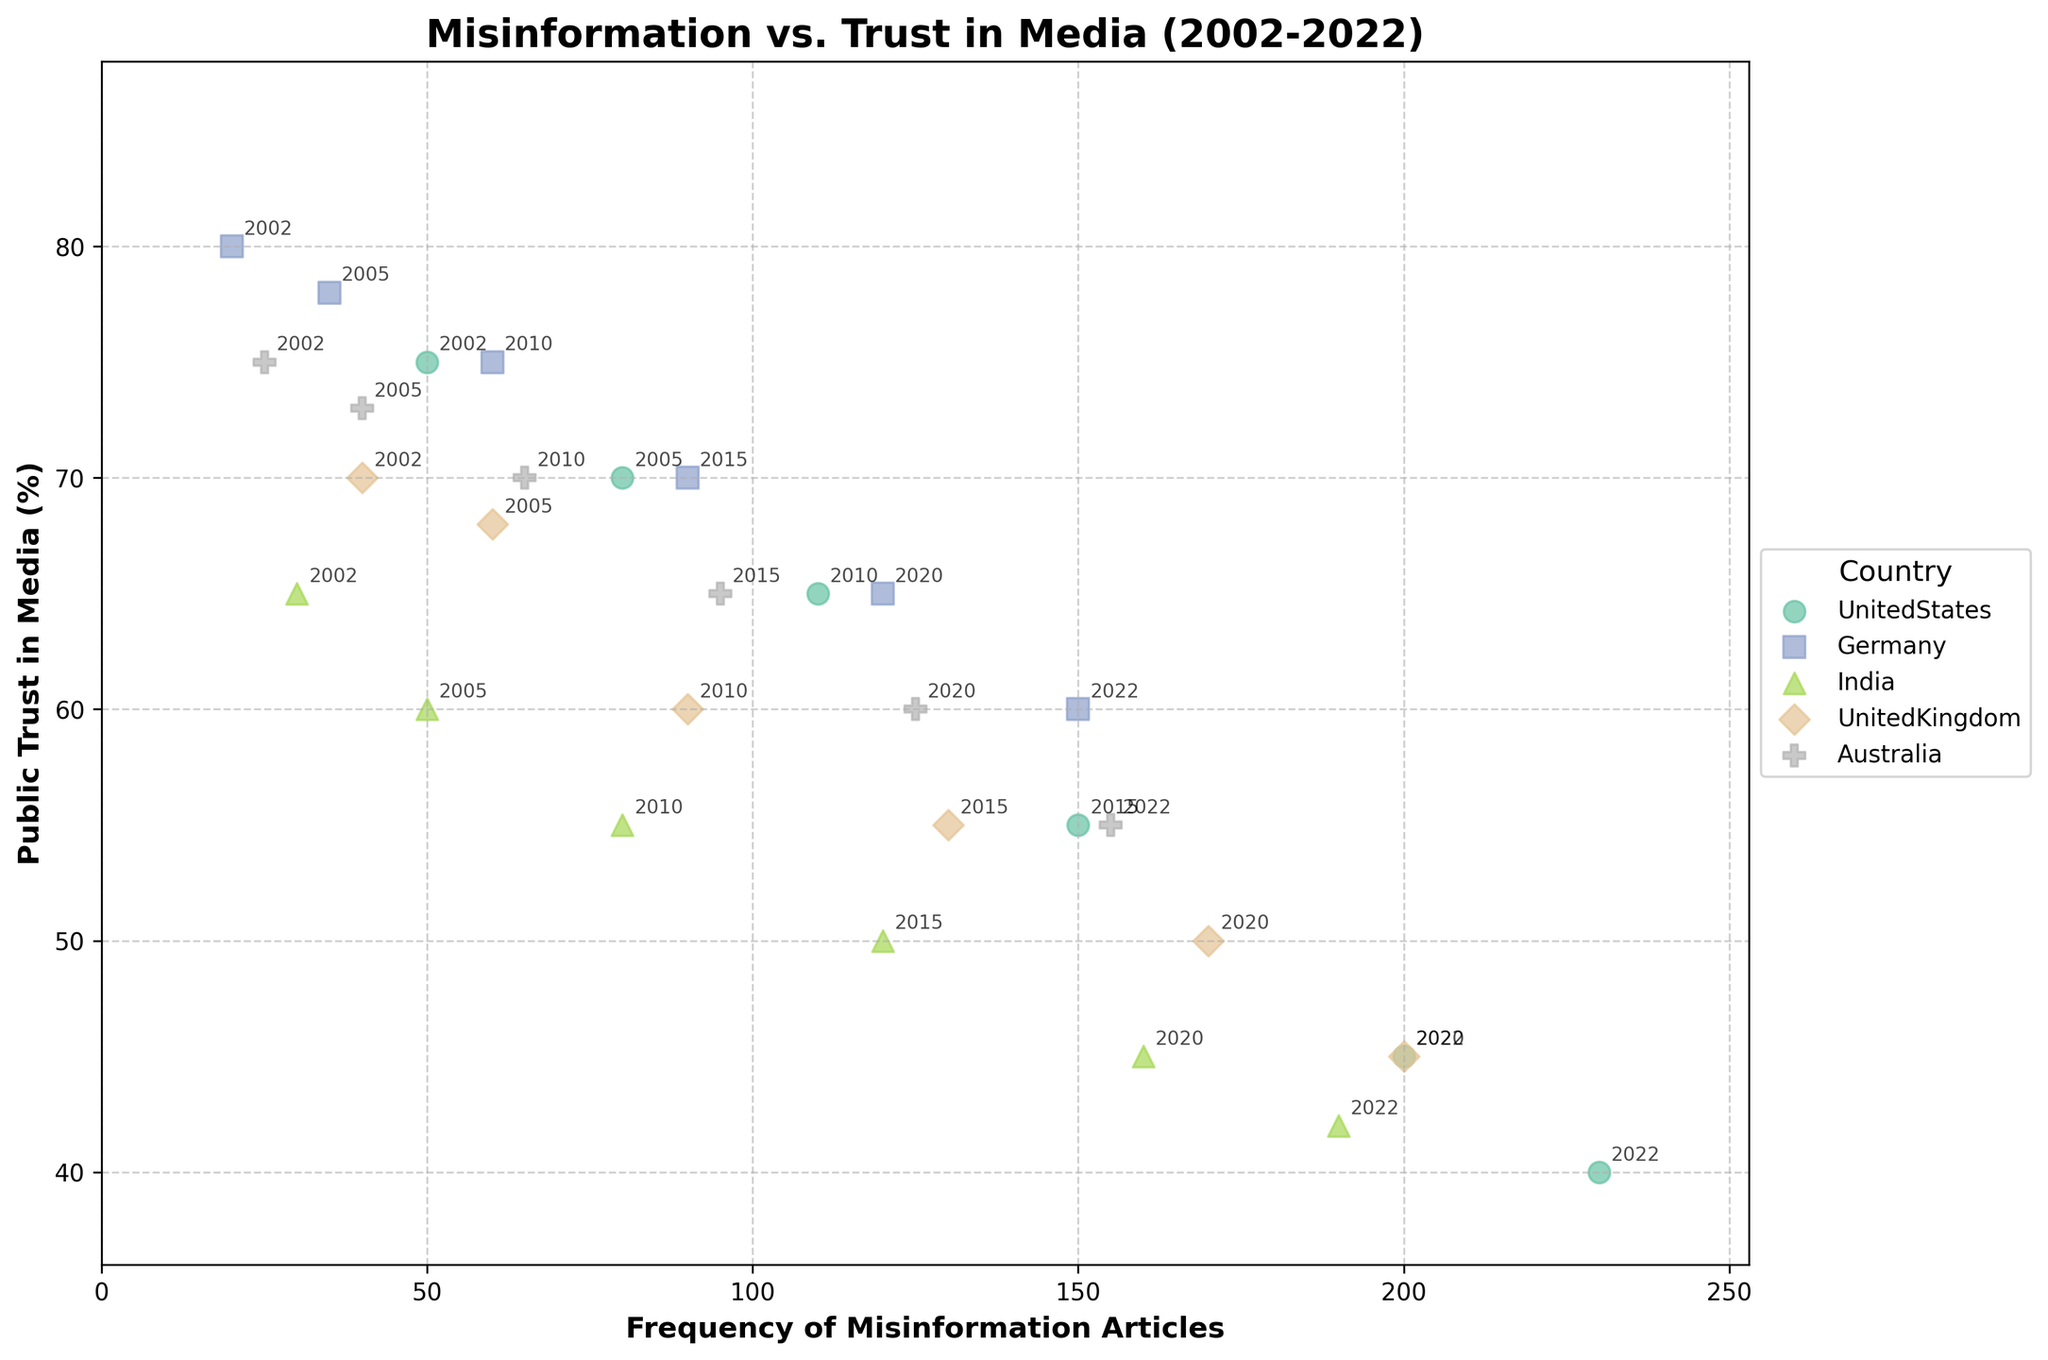How many countries are represented in the plot? The plot shows points in different colors and labels for various countries. If we count the unique colors and labels, we can determine the number of countries represented.
Answer: 5 Which country has the highest frequency of misinformation articles in 2022? By looking at the 2022 data points, we find the one with the highest value on the x-axis. The United States is positioned at 230 articles, which is the highest.
Answer: United States How did public trust in media change in Germany from 2002 to 2022? By comparing Germany's public trust in media in 2002 (80%) and 2022 (60%), we see a decrease of 20%.
Answer: Decreased by 20% Which country experienced the steepest decline in public trust in media over the two decades? Looking at the slope of the trend for each country from the starting to the ending point, India shows the steepest decline from 65% to 42%. Calculation: 65% - 42% = 23%.
Answer: India What is the overall trend between misinformation articles and public trust in media? The plot shows a general downward trend in public trust in media as the number of misinformation articles increases across different countries.
Answer: Negative correlation Which country had the lowest number of misinformation articles in 2002 and what was the corresponding trust in media? The country with the lowest value on the x-axis for the year 2002 is Germany with 20 articles and public trust of 80%.
Answer: Germany with 80% Which country has the most consistent trend in public trust compared to misinformation articles? By observing the scatter points and annotations for each country, Australia shows a slower decline in trust and a gradual increase in misinformation, indicating a more consistent trend.
Answer: Australia Between the United Kingdom and the United States, which had a greater decrease in public trust in media from 2002 to 2022? United Kingdom: 70% to 45% (25% decrease); United States: 75% to 40% (35% decrease). Thus, the United States had a greater decrease.
Answer: United States Among the represented countries, which one had the smallest increase in misinformation articles from 2002 to 2022? By comparing the differences in the number of misinformation articles from 2002 to 2022, Australia had the smallest increase, from 25 to 155 (130 articles).
Answer: Australia In which year did the United States see a sharp increase in misinformation articles, and how did public trust in media change that year? A sharp increase in misinformation articles for the United States is seen in 2015. The number of articles went from 110 to 150, and public trust dropped from 65% to 55%.
Answer: 2015, decreased 10% 